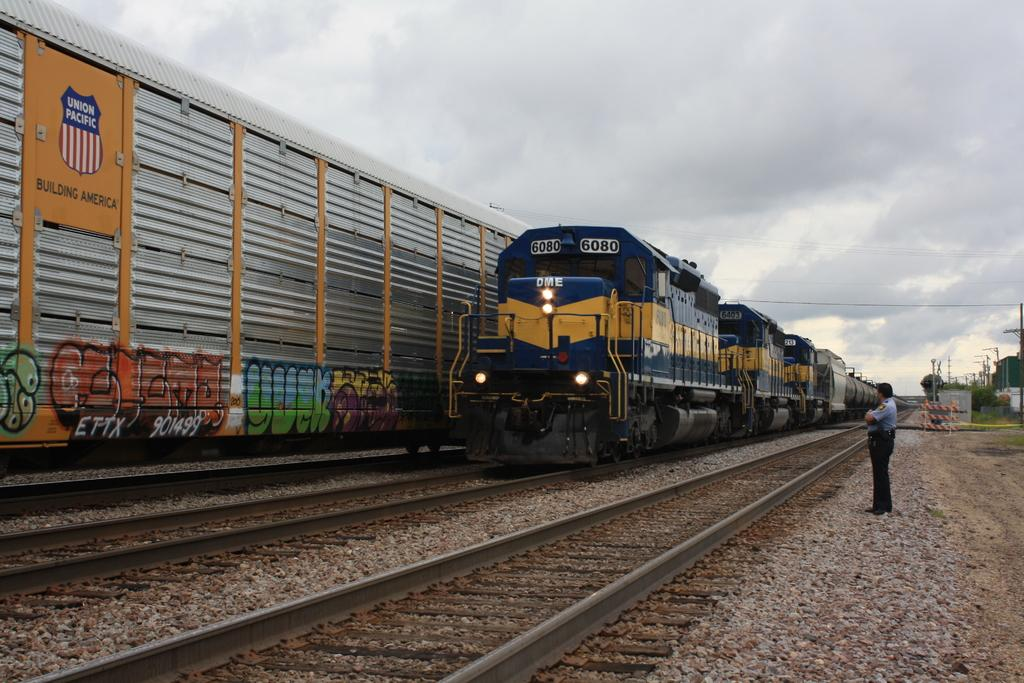What is the main subject of the image? There is a man standing in the image. What can be seen in the background of the image? There are trains on tracks, poles, trees, and the sky visible in the background of the image. What is the condition of the sky in the image? Clouds are present in the sky. How many police officers are riding bikes in the image? There are no police officers or bikes present in the image. What type of wall can be seen in the image? There is no wall present in the image. 